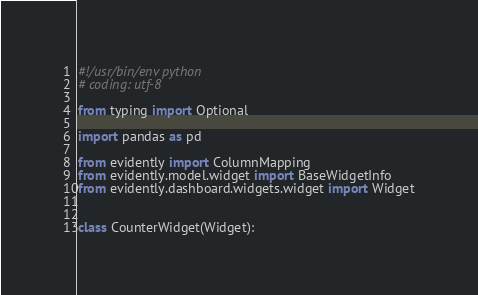Convert code to text. <code><loc_0><loc_0><loc_500><loc_500><_Python_>#!/usr/bin/env python
# coding: utf-8

from typing import Optional

import pandas as pd

from evidently import ColumnMapping
from evidently.model.widget import BaseWidgetInfo
from evidently.dashboard.widgets.widget import Widget


class CounterWidget(Widget):</code> 